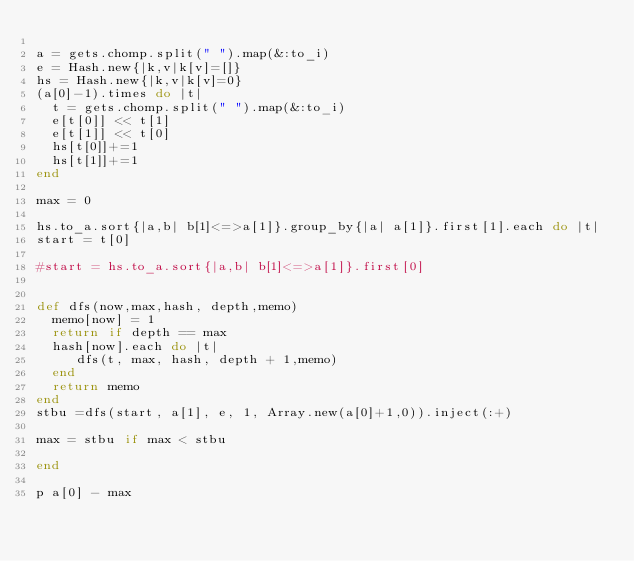<code> <loc_0><loc_0><loc_500><loc_500><_Ruby_>
a = gets.chomp.split(" ").map(&:to_i)
e = Hash.new{|k,v|k[v]=[]}
hs = Hash.new{|k,v|k[v]=0}
(a[0]-1).times do |t|
  t = gets.chomp.split(" ").map(&:to_i)
  e[t[0]] << t[1]
  e[t[1]] << t[0]
  hs[t[0]]+=1
  hs[t[1]]+=1
end

max = 0

hs.to_a.sort{|a,b| b[1]<=>a[1]}.group_by{|a| a[1]}.first[1].each do |t|
start = t[0]

#start = hs.to_a.sort{|a,b| b[1]<=>a[1]}.first[0]


def dfs(now,max,hash, depth,memo)
  memo[now] = 1
  return if depth == max
  hash[now].each do |t|
     dfs(t, max, hash, depth + 1,memo)
  end
  return memo
end
stbu =dfs(start, a[1], e, 1, Array.new(a[0]+1,0)).inject(:+)

max = stbu if max < stbu

end

p a[0] - max 


</code> 